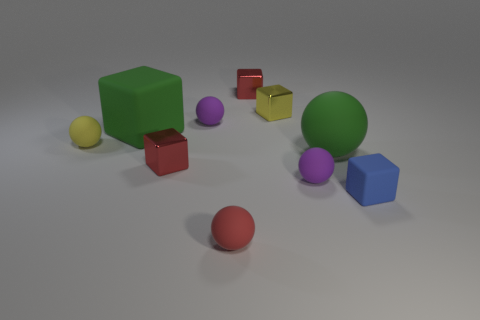There is a big sphere; what number of tiny blocks are behind it?
Keep it short and to the point. 2. Do the tiny purple object that is behind the large ball and the tiny red object behind the tiny yellow block have the same shape?
Provide a succinct answer. No. What number of other objects are there of the same color as the tiny matte cube?
Your response must be concise. 0. What is the green object on the right side of the big green matte thing that is left of the small matte ball in front of the blue object made of?
Make the answer very short. Rubber. What material is the small purple sphere behind the tiny purple thing that is in front of the tiny yellow ball made of?
Give a very brief answer. Rubber. Is the number of yellow metal cubes that are in front of the large green matte sphere less than the number of large green rubber things?
Your answer should be very brief. Yes. There is a small purple thing that is in front of the green matte cube; what is its shape?
Give a very brief answer. Sphere. There is a red rubber sphere; is its size the same as the red cube in front of the tiny yellow matte ball?
Offer a very short reply. Yes. Is there a purple ball that has the same material as the green cube?
Ensure brevity in your answer.  Yes. How many cylinders are either tiny yellow objects or metallic objects?
Give a very brief answer. 0. 